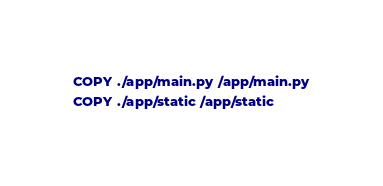Convert code to text. <code><loc_0><loc_0><loc_500><loc_500><_Dockerfile_>
COPY ./app/main.py /app/main.py
COPY ./app/static /app/static
</code> 